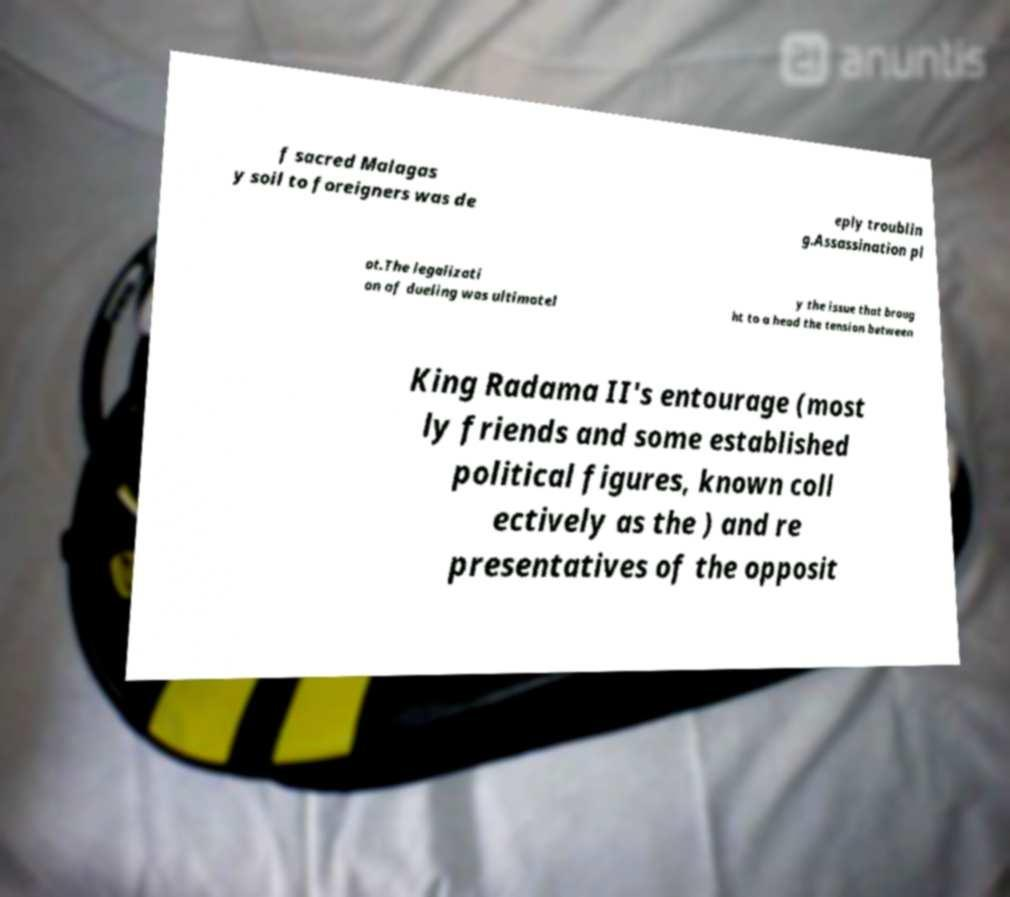Can you read and provide the text displayed in the image?This photo seems to have some interesting text. Can you extract and type it out for me? f sacred Malagas y soil to foreigners was de eply troublin g.Assassination pl ot.The legalizati on of dueling was ultimatel y the issue that broug ht to a head the tension between King Radama II's entourage (most ly friends and some established political figures, known coll ectively as the ) and re presentatives of the opposit 